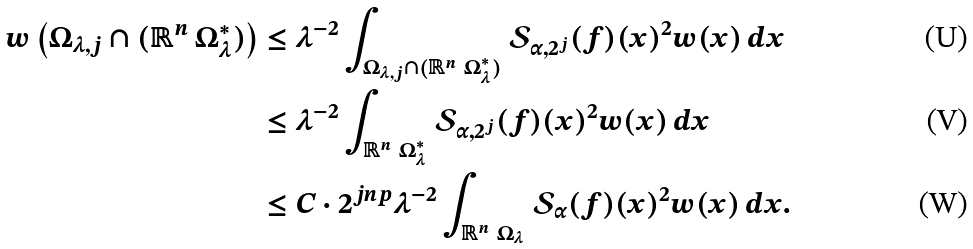Convert formula to latex. <formula><loc_0><loc_0><loc_500><loc_500>w \left ( \Omega _ { \lambda , j } \cap ( \mathbb { R } ^ { n } \ \Omega ^ { * } _ { \lambda } ) \right ) & \leq \lambda ^ { - 2 } \int _ { \Omega _ { \lambda , j } \cap ( \mathbb { R } ^ { n } \ \Omega ^ { * } _ { \lambda } ) } \mathcal { S } _ { \alpha , 2 ^ { j } } ( f ) ( x ) ^ { 2 } w ( x ) \, d x \\ & \leq \lambda ^ { - 2 } \int _ { \mathbb { R } ^ { n } \ \Omega ^ { * } _ { \lambda } } \mathcal { S } _ { \alpha , 2 ^ { j } } ( f ) ( x ) ^ { 2 } w ( x ) \, d x \\ & \leq C \cdot 2 ^ { j n p } \lambda ^ { - 2 } \int _ { \mathbb { R } ^ { n } \ \Omega _ { \lambda } } \mathcal { S } _ { \alpha } ( f ) ( x ) ^ { 2 } w ( x ) \, d x .</formula> 